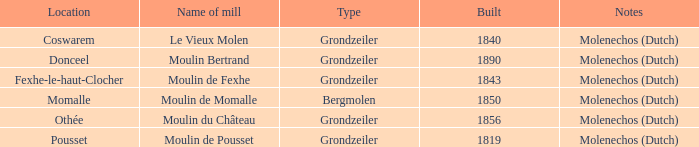What is the Location of the Moulin Bertrand Mill? Donceel. 